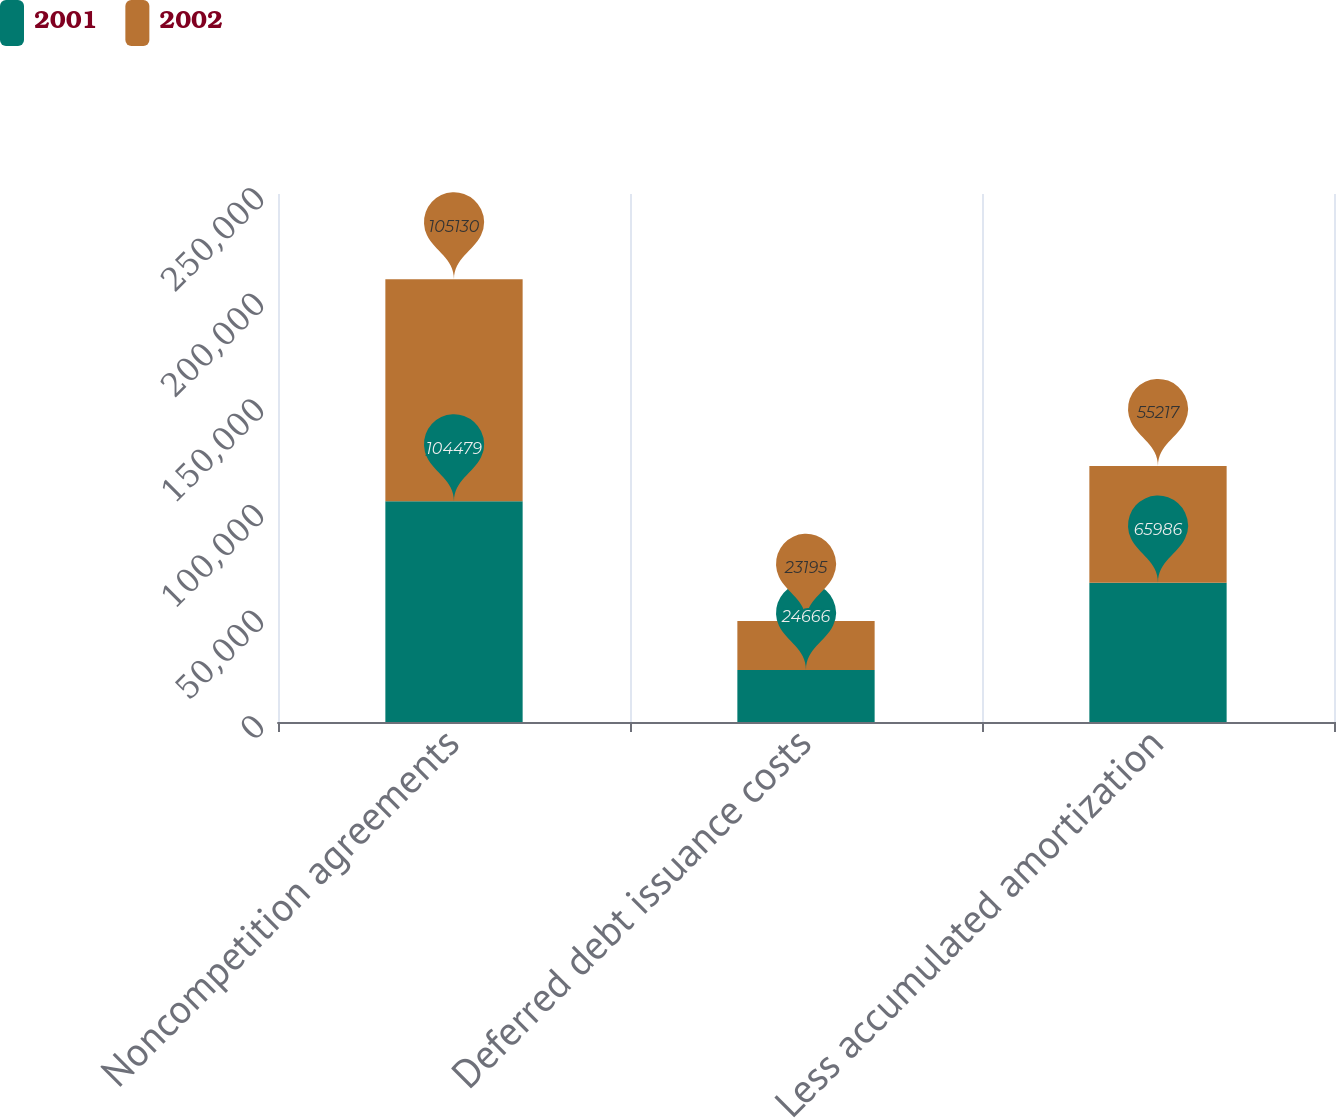Convert chart. <chart><loc_0><loc_0><loc_500><loc_500><stacked_bar_chart><ecel><fcel>Noncompetition agreements<fcel>Deferred debt issuance costs<fcel>Less accumulated amortization<nl><fcel>2001<fcel>104479<fcel>24666<fcel>65986<nl><fcel>2002<fcel>105130<fcel>23195<fcel>55217<nl></chart> 